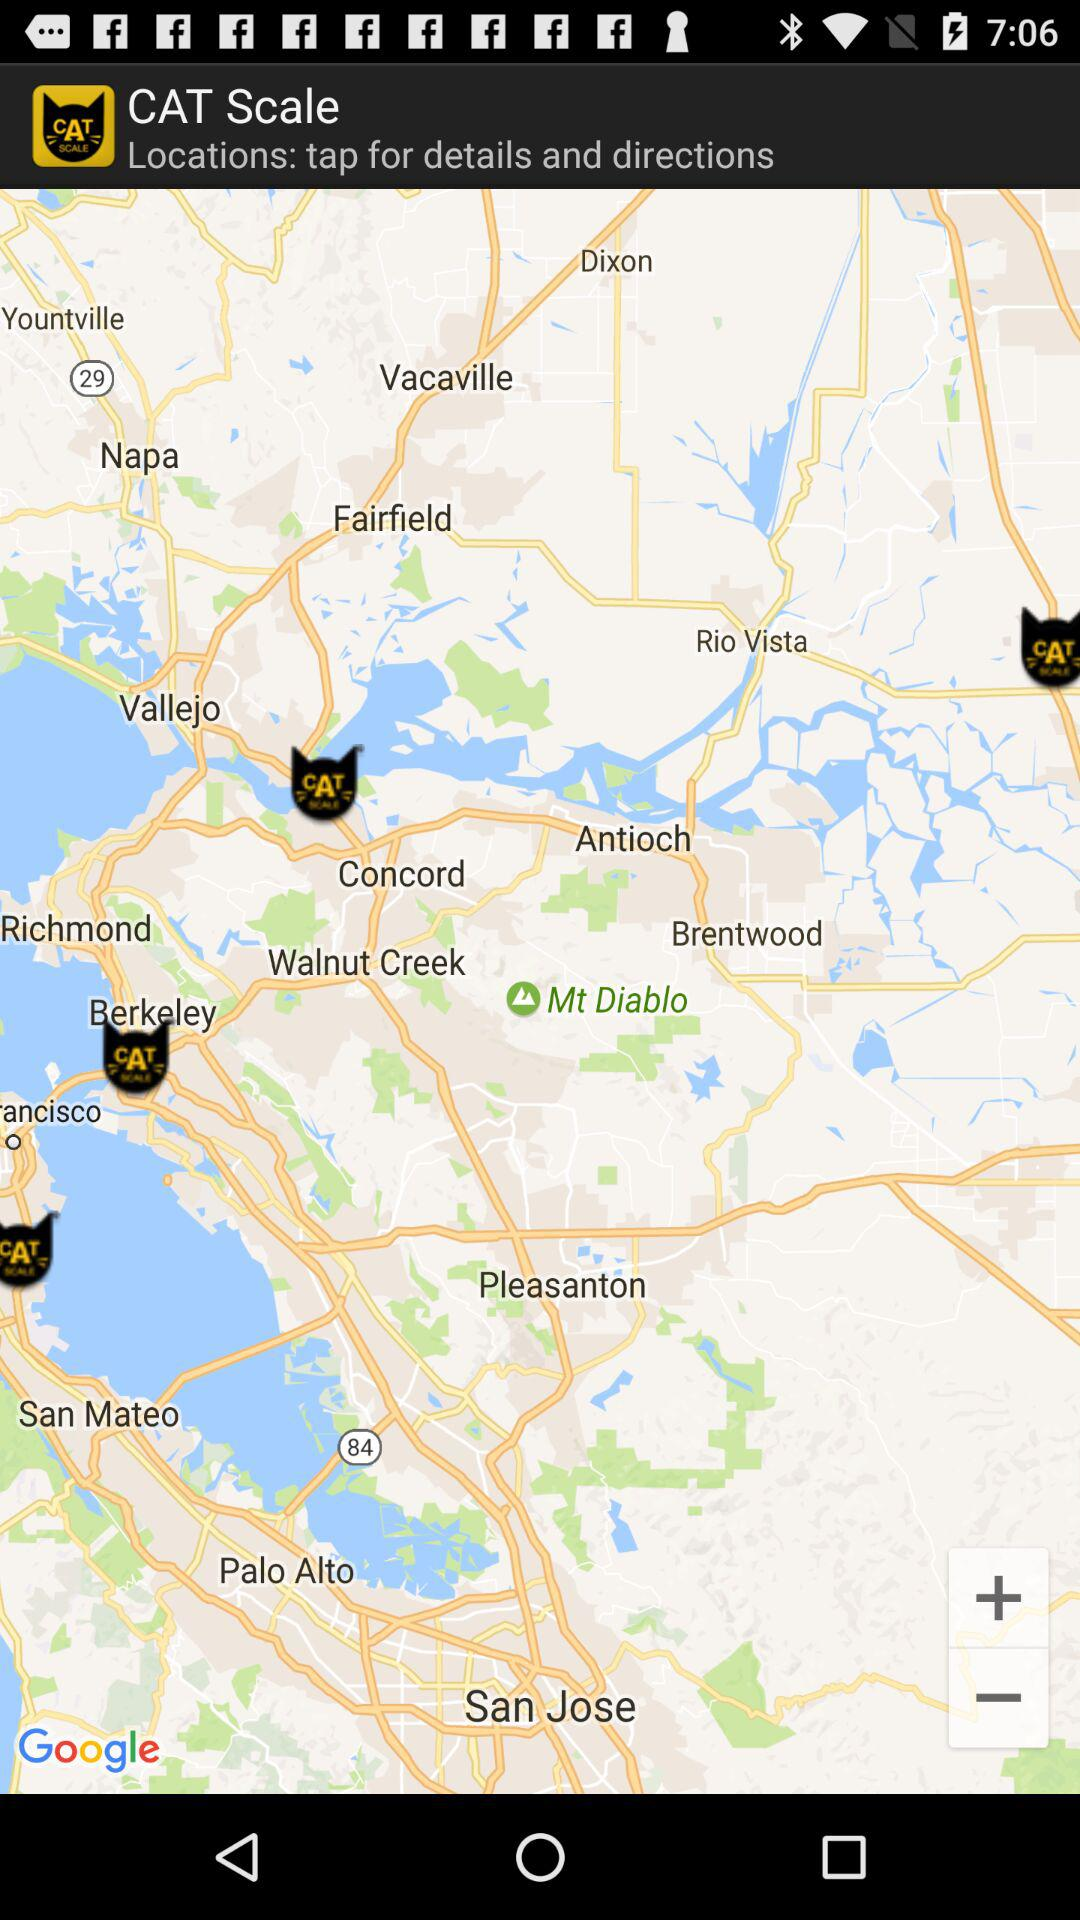What is the app name? The app name is "CAT Scale". 